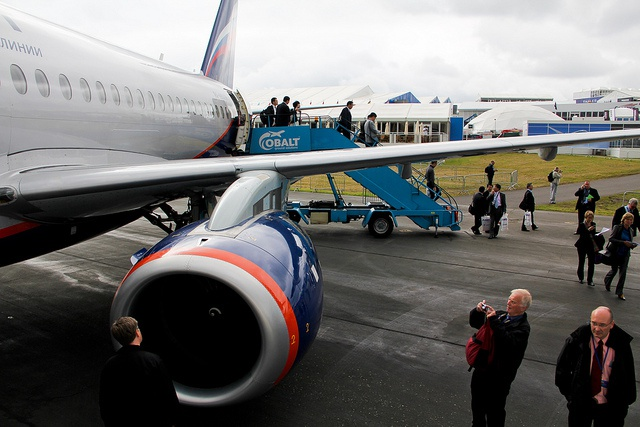Describe the objects in this image and their specific colors. I can see airplane in white, black, lightgray, darkgray, and gray tones, people in white, black, gray, lightgray, and darkgray tones, people in white, black, gray, brown, and maroon tones, people in white, black, maroon, gray, and brown tones, and people in white, black, maroon, and gray tones in this image. 